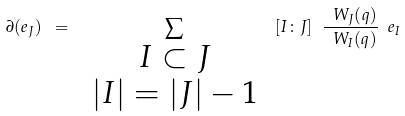Convert formula to latex. <formula><loc_0><loc_0><loc_500><loc_500>\partial ( e _ { J } ) \ = \ \sum _ { \begin{array} { c } I \subset J \\ | I | = | J | - 1 \end{array} } \ [ I \colon J ] \ \frac { \ W _ { J } ( q ) } { \ W _ { I } ( q ) } \ e _ { I }</formula> 